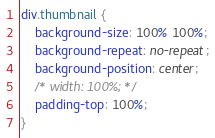<code> <loc_0><loc_0><loc_500><loc_500><_CSS_>div.thumbnail {
    background-size: 100% 100%;
    background-repeat: no-repeat;
    background-position: center;
    /* width: 100%; */
    padding-top: 100%;
}</code> 